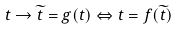<formula> <loc_0><loc_0><loc_500><loc_500>t \rightarrow \widetilde { t } = g ( t ) \Leftrightarrow t = f ( \widetilde { t } )</formula> 